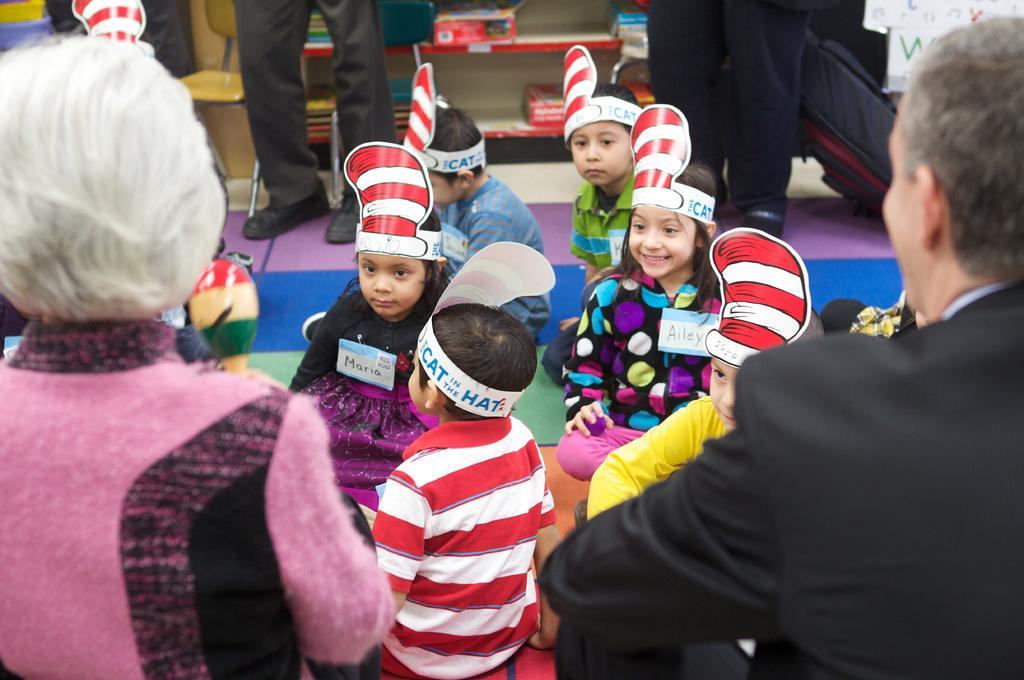In one or two sentences, can you explain what this image depicts? In this image we can see a few people, some of them are wearing hats with text on them, there are boxes, and books on the racks, also we can see a chair. 